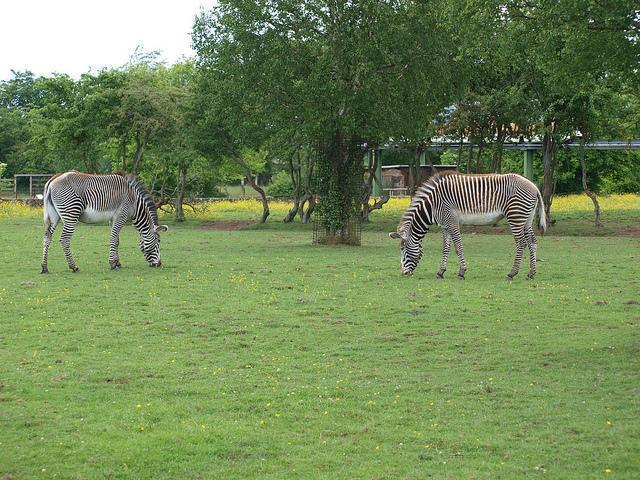The zebras in the middle of the field are busy doing what?
From the following set of four choices, select the accurate answer to respond to the question.
Options: Running, walking, eating grass, pointing nose. Eating grass. 